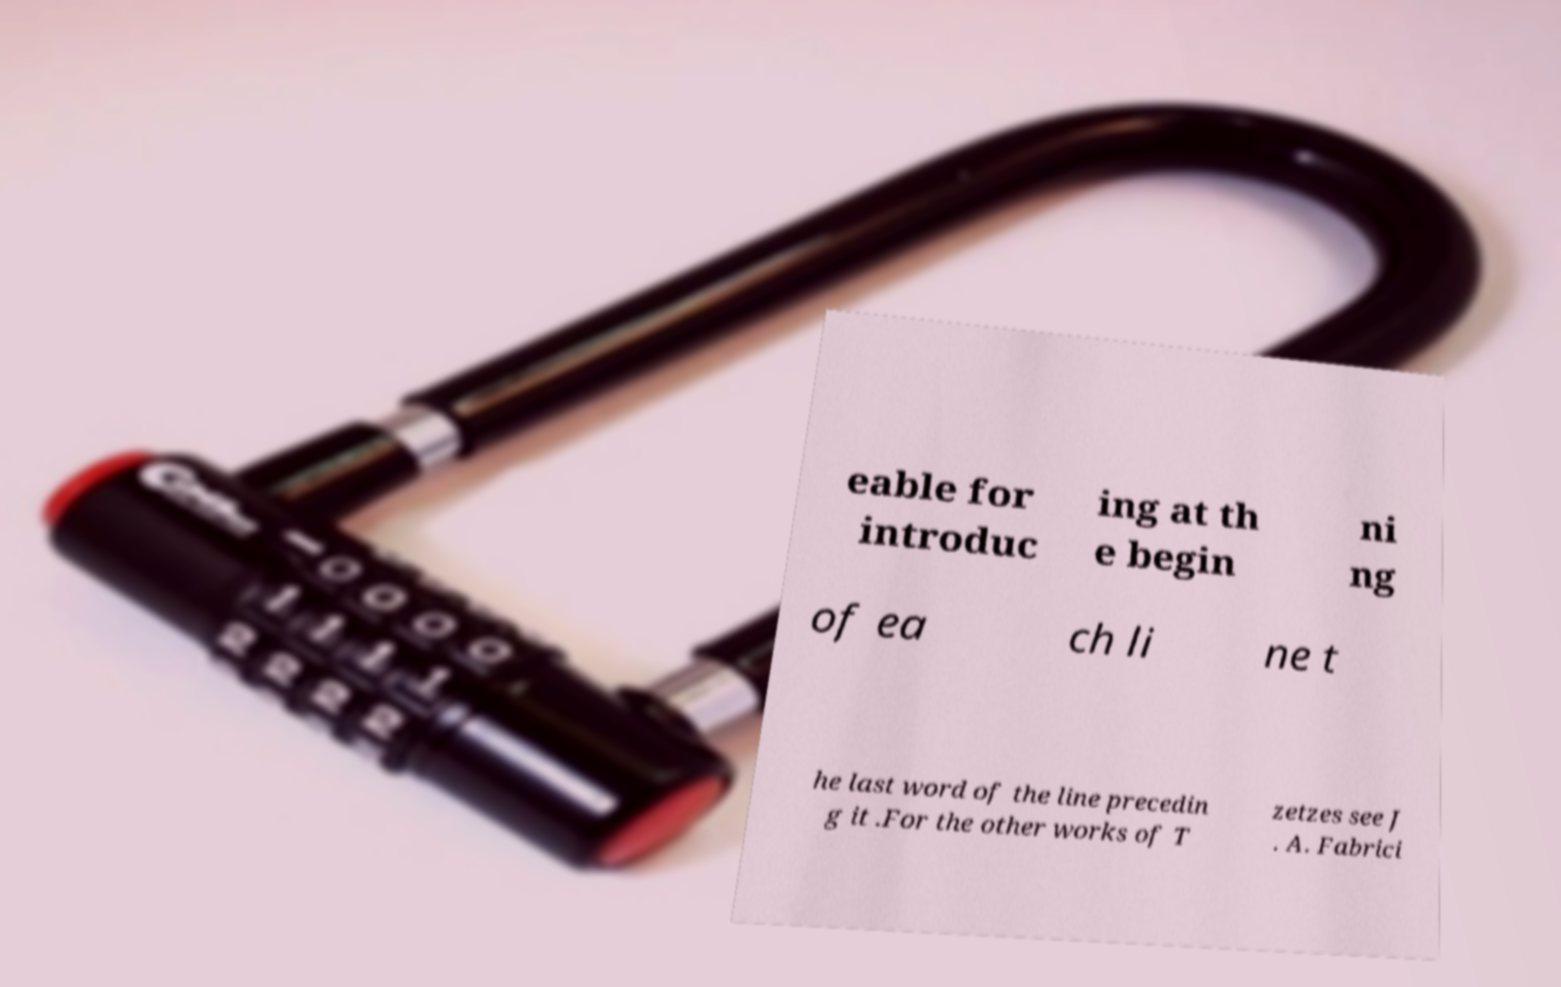Could you assist in decoding the text presented in this image and type it out clearly? eable for introduc ing at th e begin ni ng of ea ch li ne t he last word of the line precedin g it .For the other works of T zetzes see J . A. Fabrici 